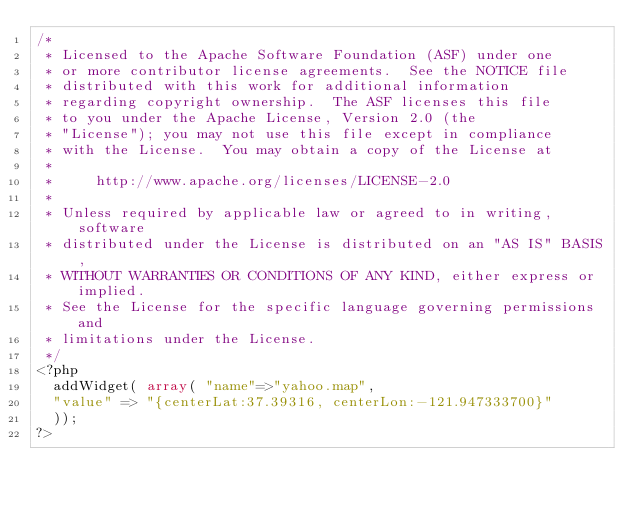<code> <loc_0><loc_0><loc_500><loc_500><_PHP_>/*
 * Licensed to the Apache Software Foundation (ASF) under one
 * or more contributor license agreements.  See the NOTICE file
 * distributed with this work for additional information
 * regarding copyright ownership.  The ASF licenses this file
 * to you under the Apache License, Version 2.0 (the
 * "License"); you may not use this file except in compliance
 * with the License.  You may obtain a copy of the License at
 *
 *     http://www.apache.org/licenses/LICENSE-2.0
 *
 * Unless required by applicable law or agreed to in writing, software
 * distributed under the License is distributed on an "AS IS" BASIS,
 * WITHOUT WARRANTIES OR CONDITIONS OF ANY KIND, either express or implied.
 * See the License for the specific language governing permissions and
 * limitations under the License.
 */ 
<?php
  addWidget( array( "name"=>"yahoo.map", 
	"value" => "{centerLat:37.39316, centerLon:-121.947333700}" 
  ));
?></code> 